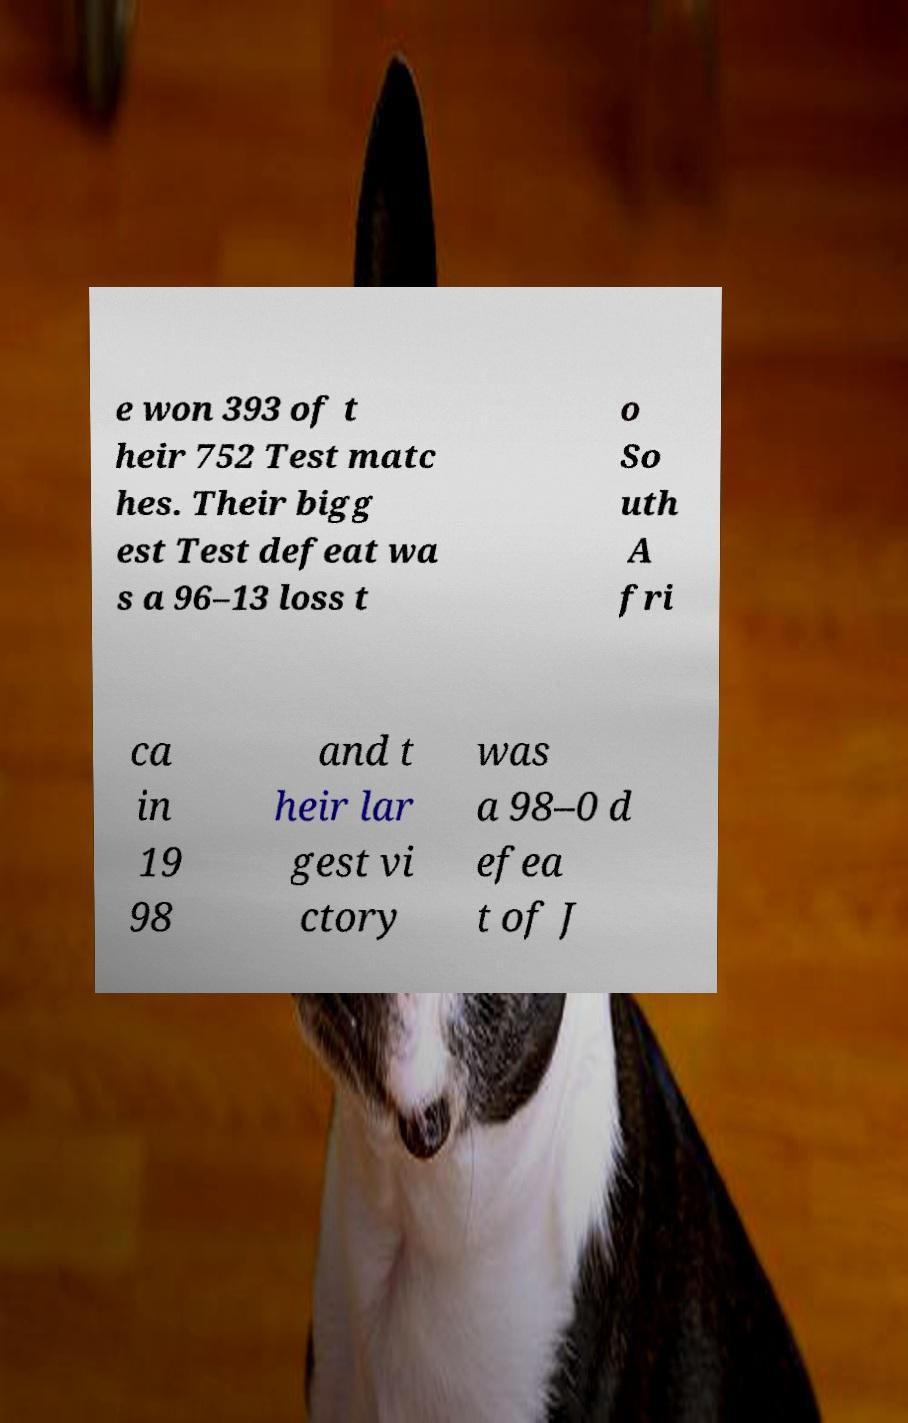There's text embedded in this image that I need extracted. Can you transcribe it verbatim? e won 393 of t heir 752 Test matc hes. Their bigg est Test defeat wa s a 96–13 loss t o So uth A fri ca in 19 98 and t heir lar gest vi ctory was a 98–0 d efea t of J 